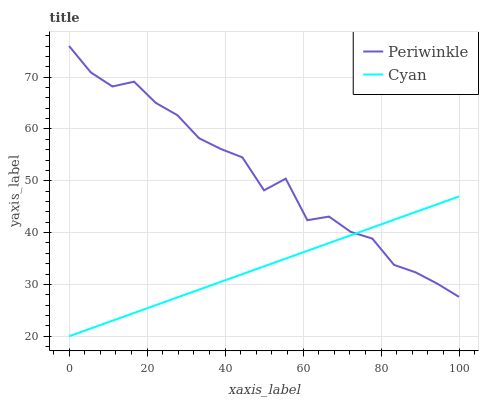Does Periwinkle have the minimum area under the curve?
Answer yes or no. No. Is Periwinkle the smoothest?
Answer yes or no. No. Does Periwinkle have the lowest value?
Answer yes or no. No. 